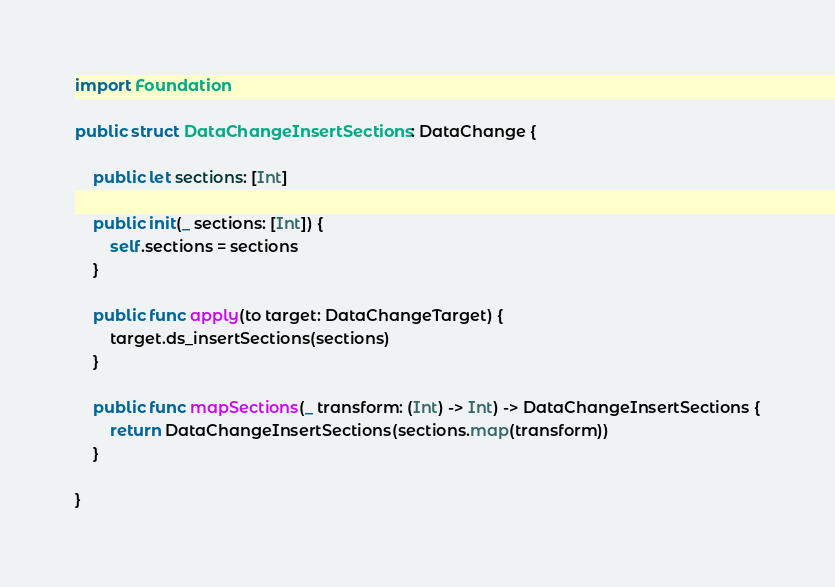<code> <loc_0><loc_0><loc_500><loc_500><_Swift_>
import Foundation

public struct DataChangeInsertSections: DataChange {

	public let sections: [Int]

	public init(_ sections: [Int]) {
		self.sections = sections
	}

	public func apply(to target: DataChangeTarget) {
		target.ds_insertSections(sections)
	}

	public func mapSections(_ transform: (Int) -> Int) -> DataChangeInsertSections {
		return DataChangeInsertSections(sections.map(transform))
	}

}
</code> 